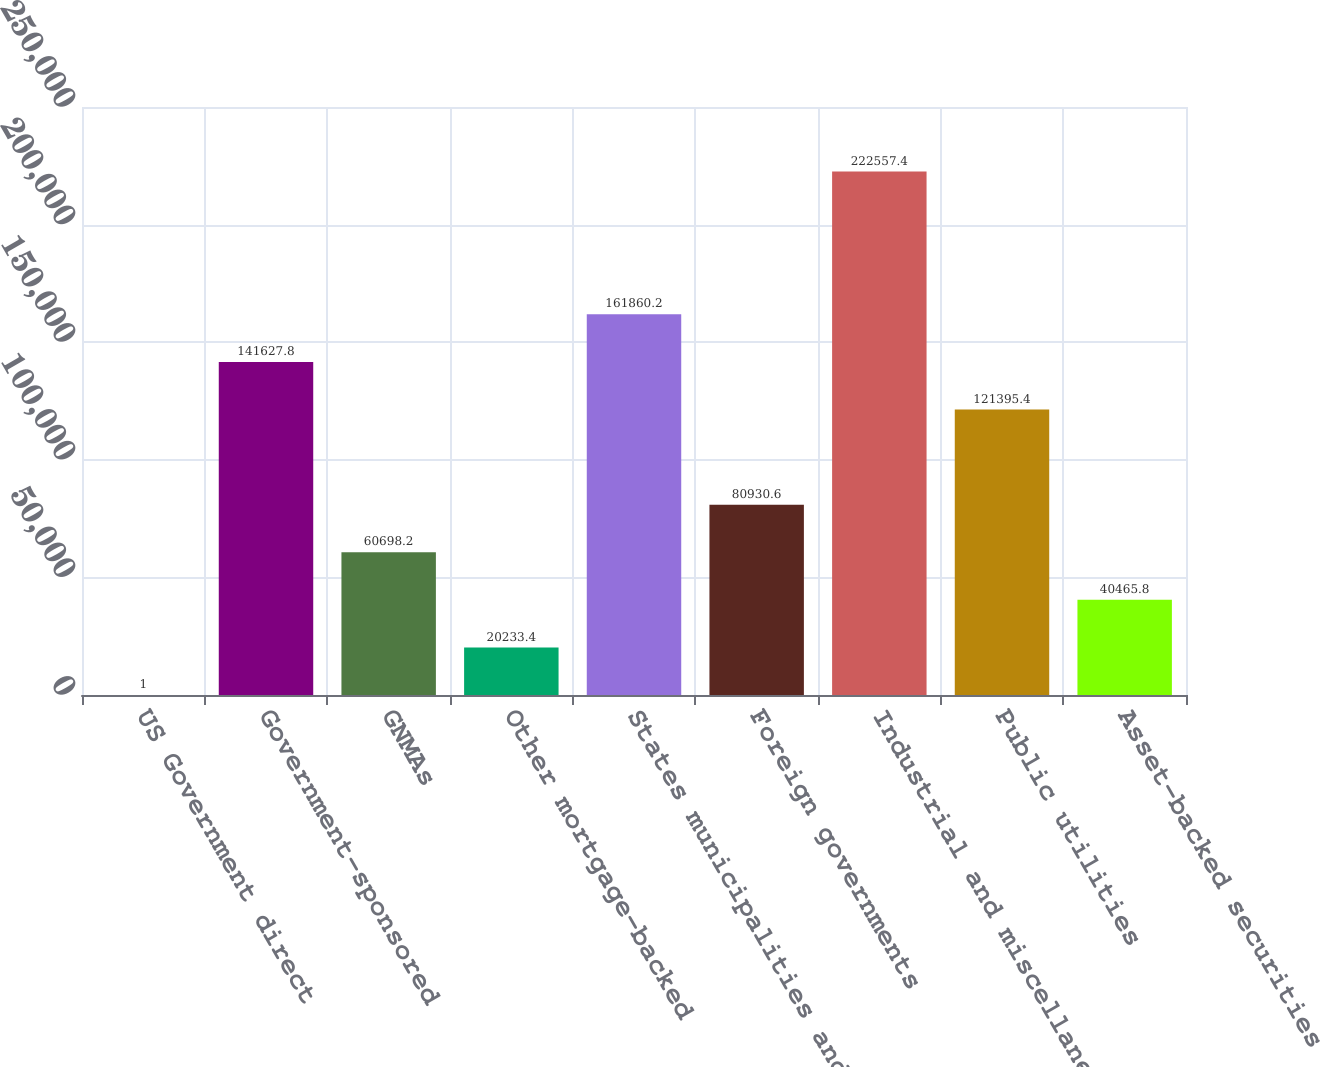<chart> <loc_0><loc_0><loc_500><loc_500><bar_chart><fcel>US Government direct<fcel>Government-sponsored<fcel>GNMAs<fcel>Other mortgage-backed<fcel>States municipalities and<fcel>Foreign governments<fcel>Industrial and miscellaneous<fcel>Public utilities<fcel>Asset-backed securities<nl><fcel>1<fcel>141628<fcel>60698.2<fcel>20233.4<fcel>161860<fcel>80930.6<fcel>222557<fcel>121395<fcel>40465.8<nl></chart> 